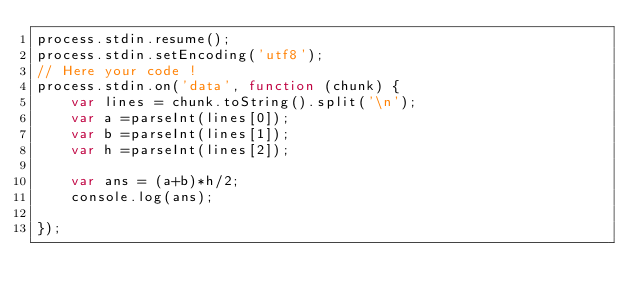Convert code to text. <code><loc_0><loc_0><loc_500><loc_500><_JavaScript_>process.stdin.resume();
process.stdin.setEncoding('utf8');
// Here your code !
process.stdin.on('data', function (chunk) {
    var lines = chunk.toString().split('\n');
    var a =parseInt(lines[0]);
    var b =parseInt(lines[1]);
    var h =parseInt(lines[2]);
    
    var ans = (a+b)*h/2;
    console.log(ans);
    
});
</code> 